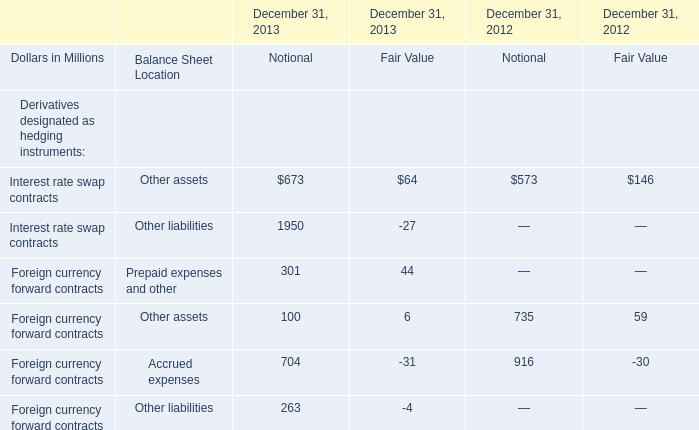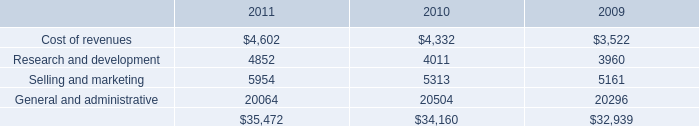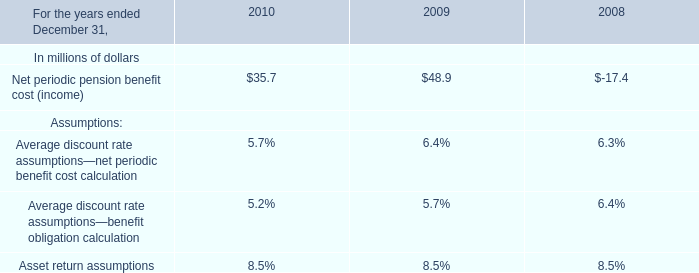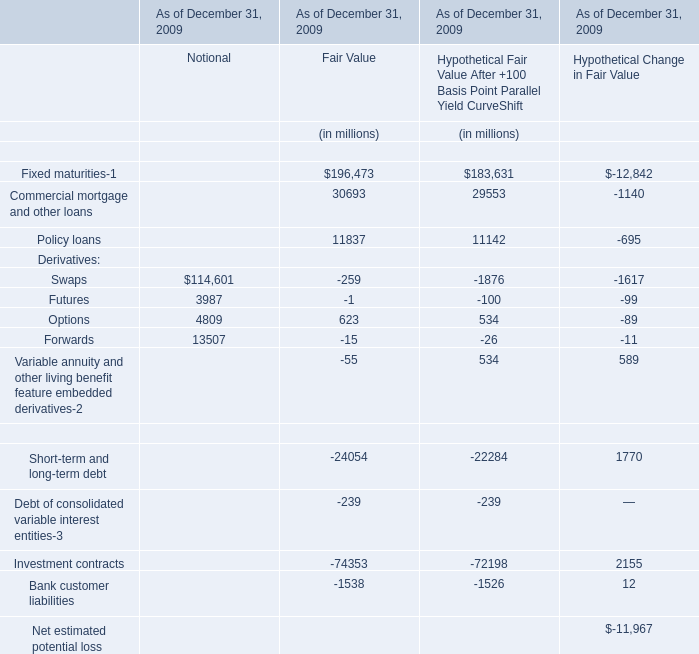what's the total amount of Interest rate swap contracts of December 31, 2013 Notional, and Research and development of 2011 ? 
Computations: (1950.0 + 4852.0)
Answer: 6802.0. 